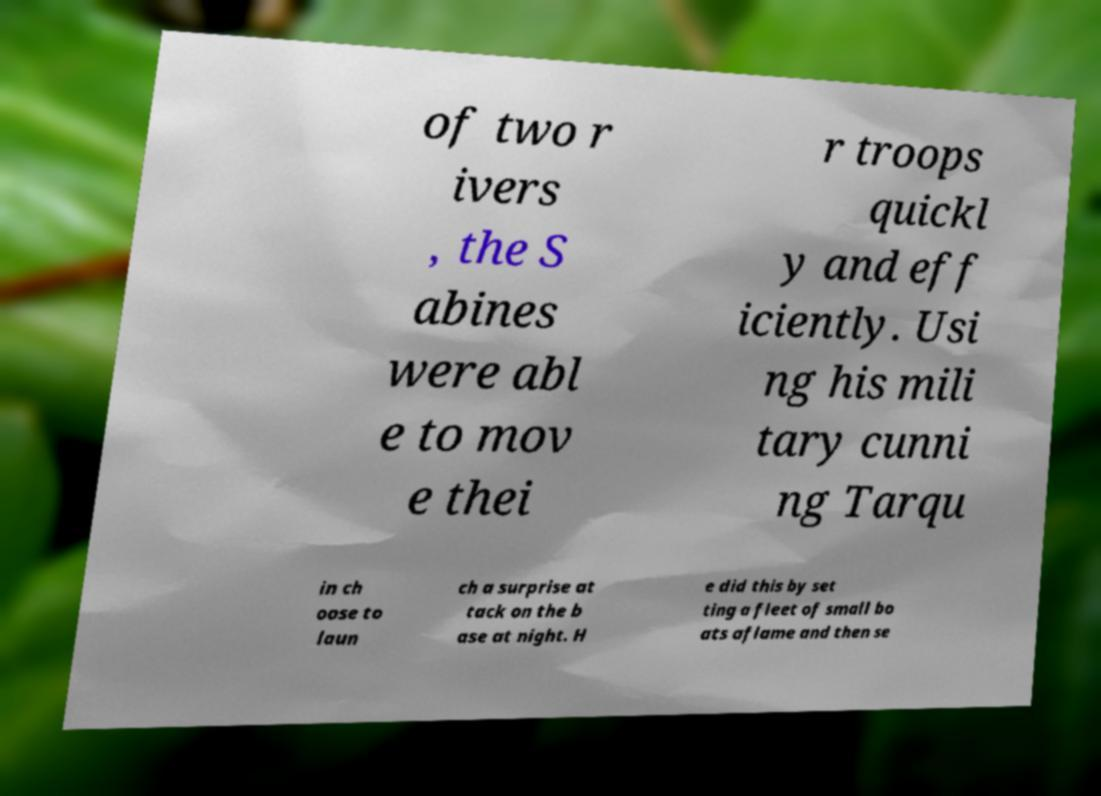Could you extract and type out the text from this image? of two r ivers , the S abines were abl e to mov e thei r troops quickl y and eff iciently. Usi ng his mili tary cunni ng Tarqu in ch oose to laun ch a surprise at tack on the b ase at night. H e did this by set ting a fleet of small bo ats aflame and then se 